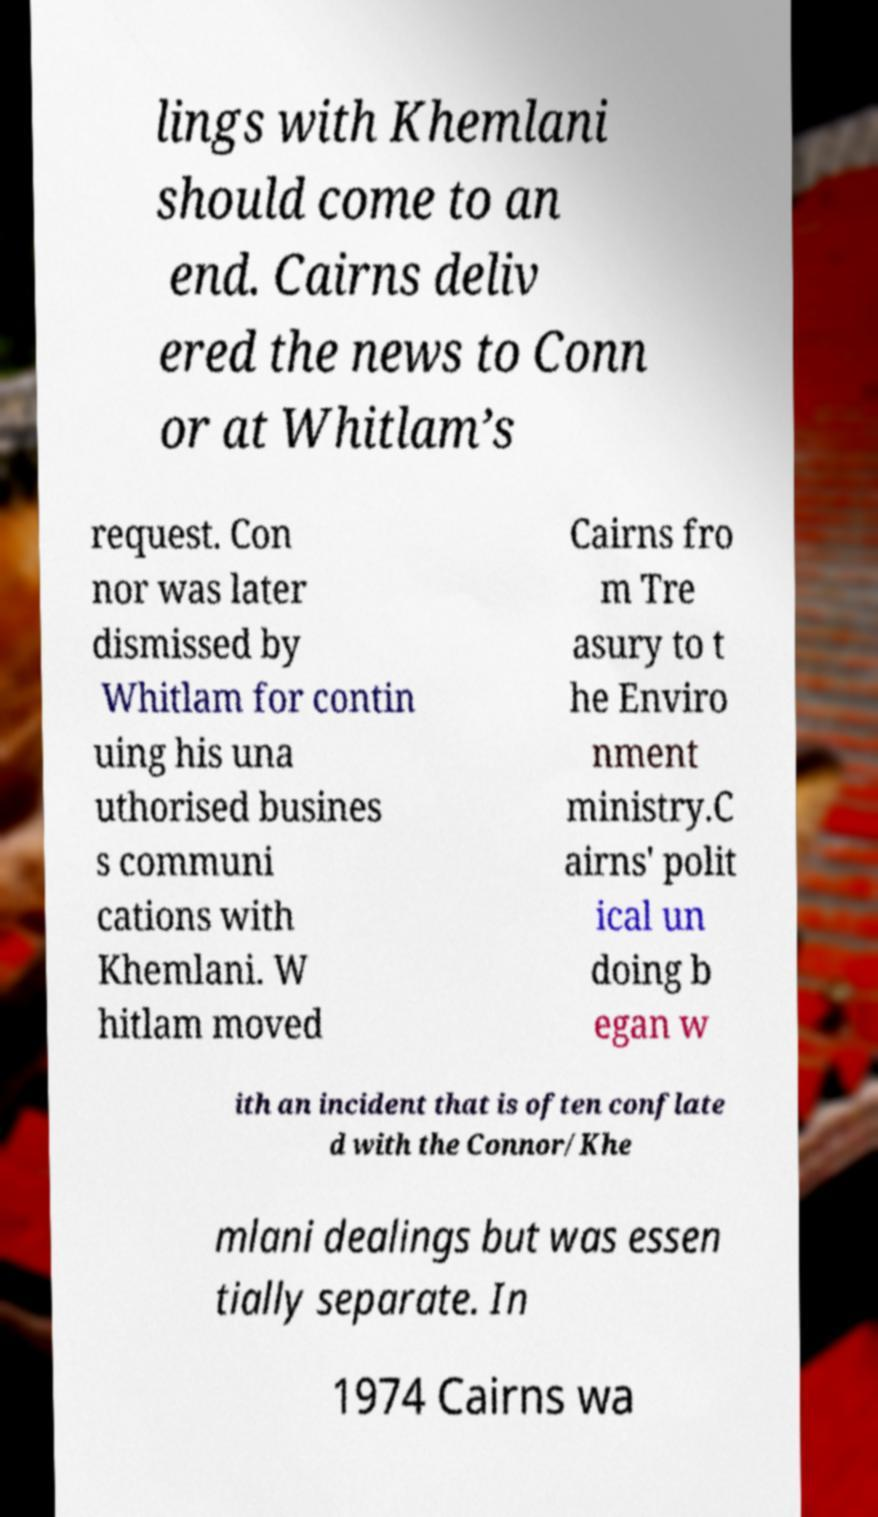There's text embedded in this image that I need extracted. Can you transcribe it verbatim? lings with Khemlani should come to an end. Cairns deliv ered the news to Conn or at Whitlam’s request. Con nor was later dismissed by Whitlam for contin uing his una uthorised busines s communi cations with Khemlani. W hitlam moved Cairns fro m Tre asury to t he Enviro nment ministry.C airns' polit ical un doing b egan w ith an incident that is often conflate d with the Connor/Khe mlani dealings but was essen tially separate. In 1974 Cairns wa 